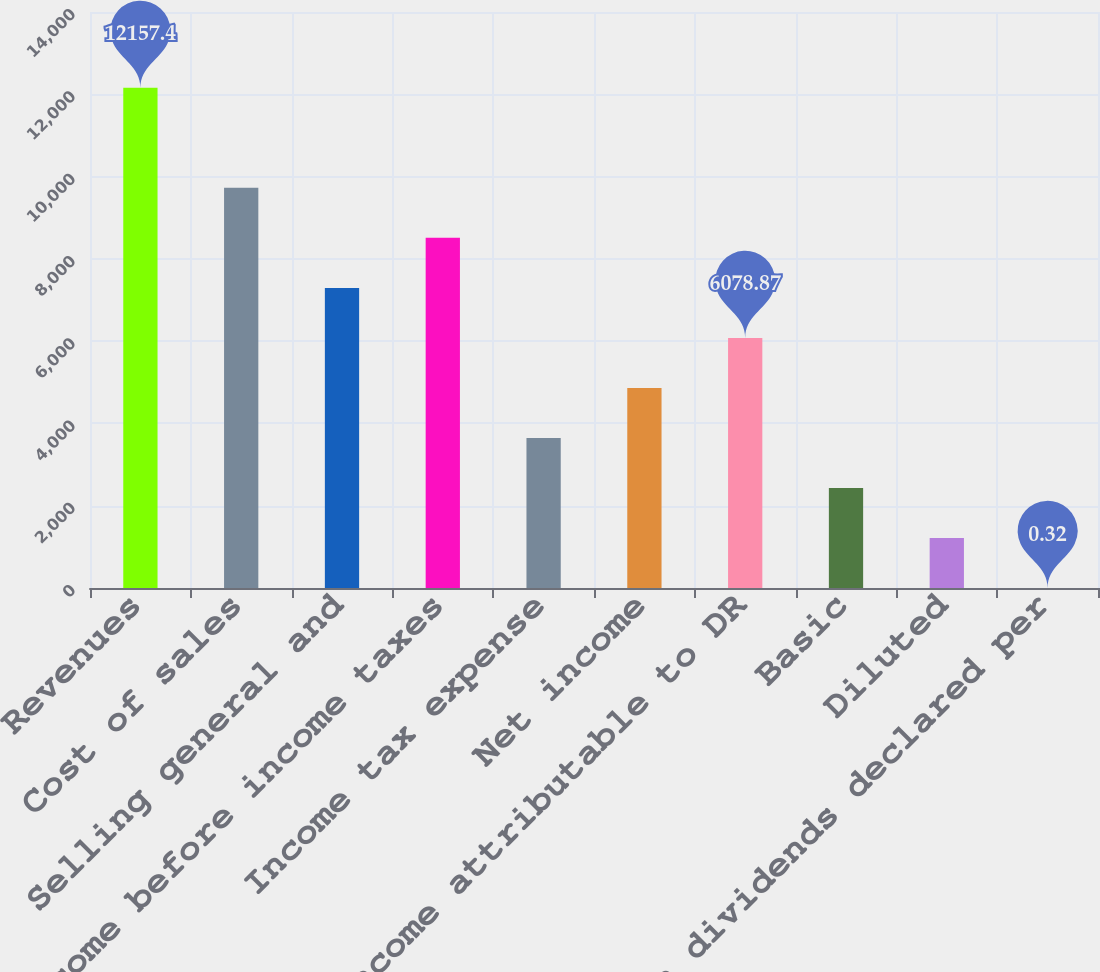<chart> <loc_0><loc_0><loc_500><loc_500><bar_chart><fcel>Revenues<fcel>Cost of sales<fcel>Selling general and<fcel>Income before income taxes<fcel>Income tax expense<fcel>Net income<fcel>Net income attributable to DR<fcel>Basic<fcel>Diluted<fcel>Cash dividends declared per<nl><fcel>12157.4<fcel>9726<fcel>7294.58<fcel>8510.29<fcel>3647.45<fcel>4863.16<fcel>6078.87<fcel>2431.74<fcel>1216.03<fcel>0.32<nl></chart> 